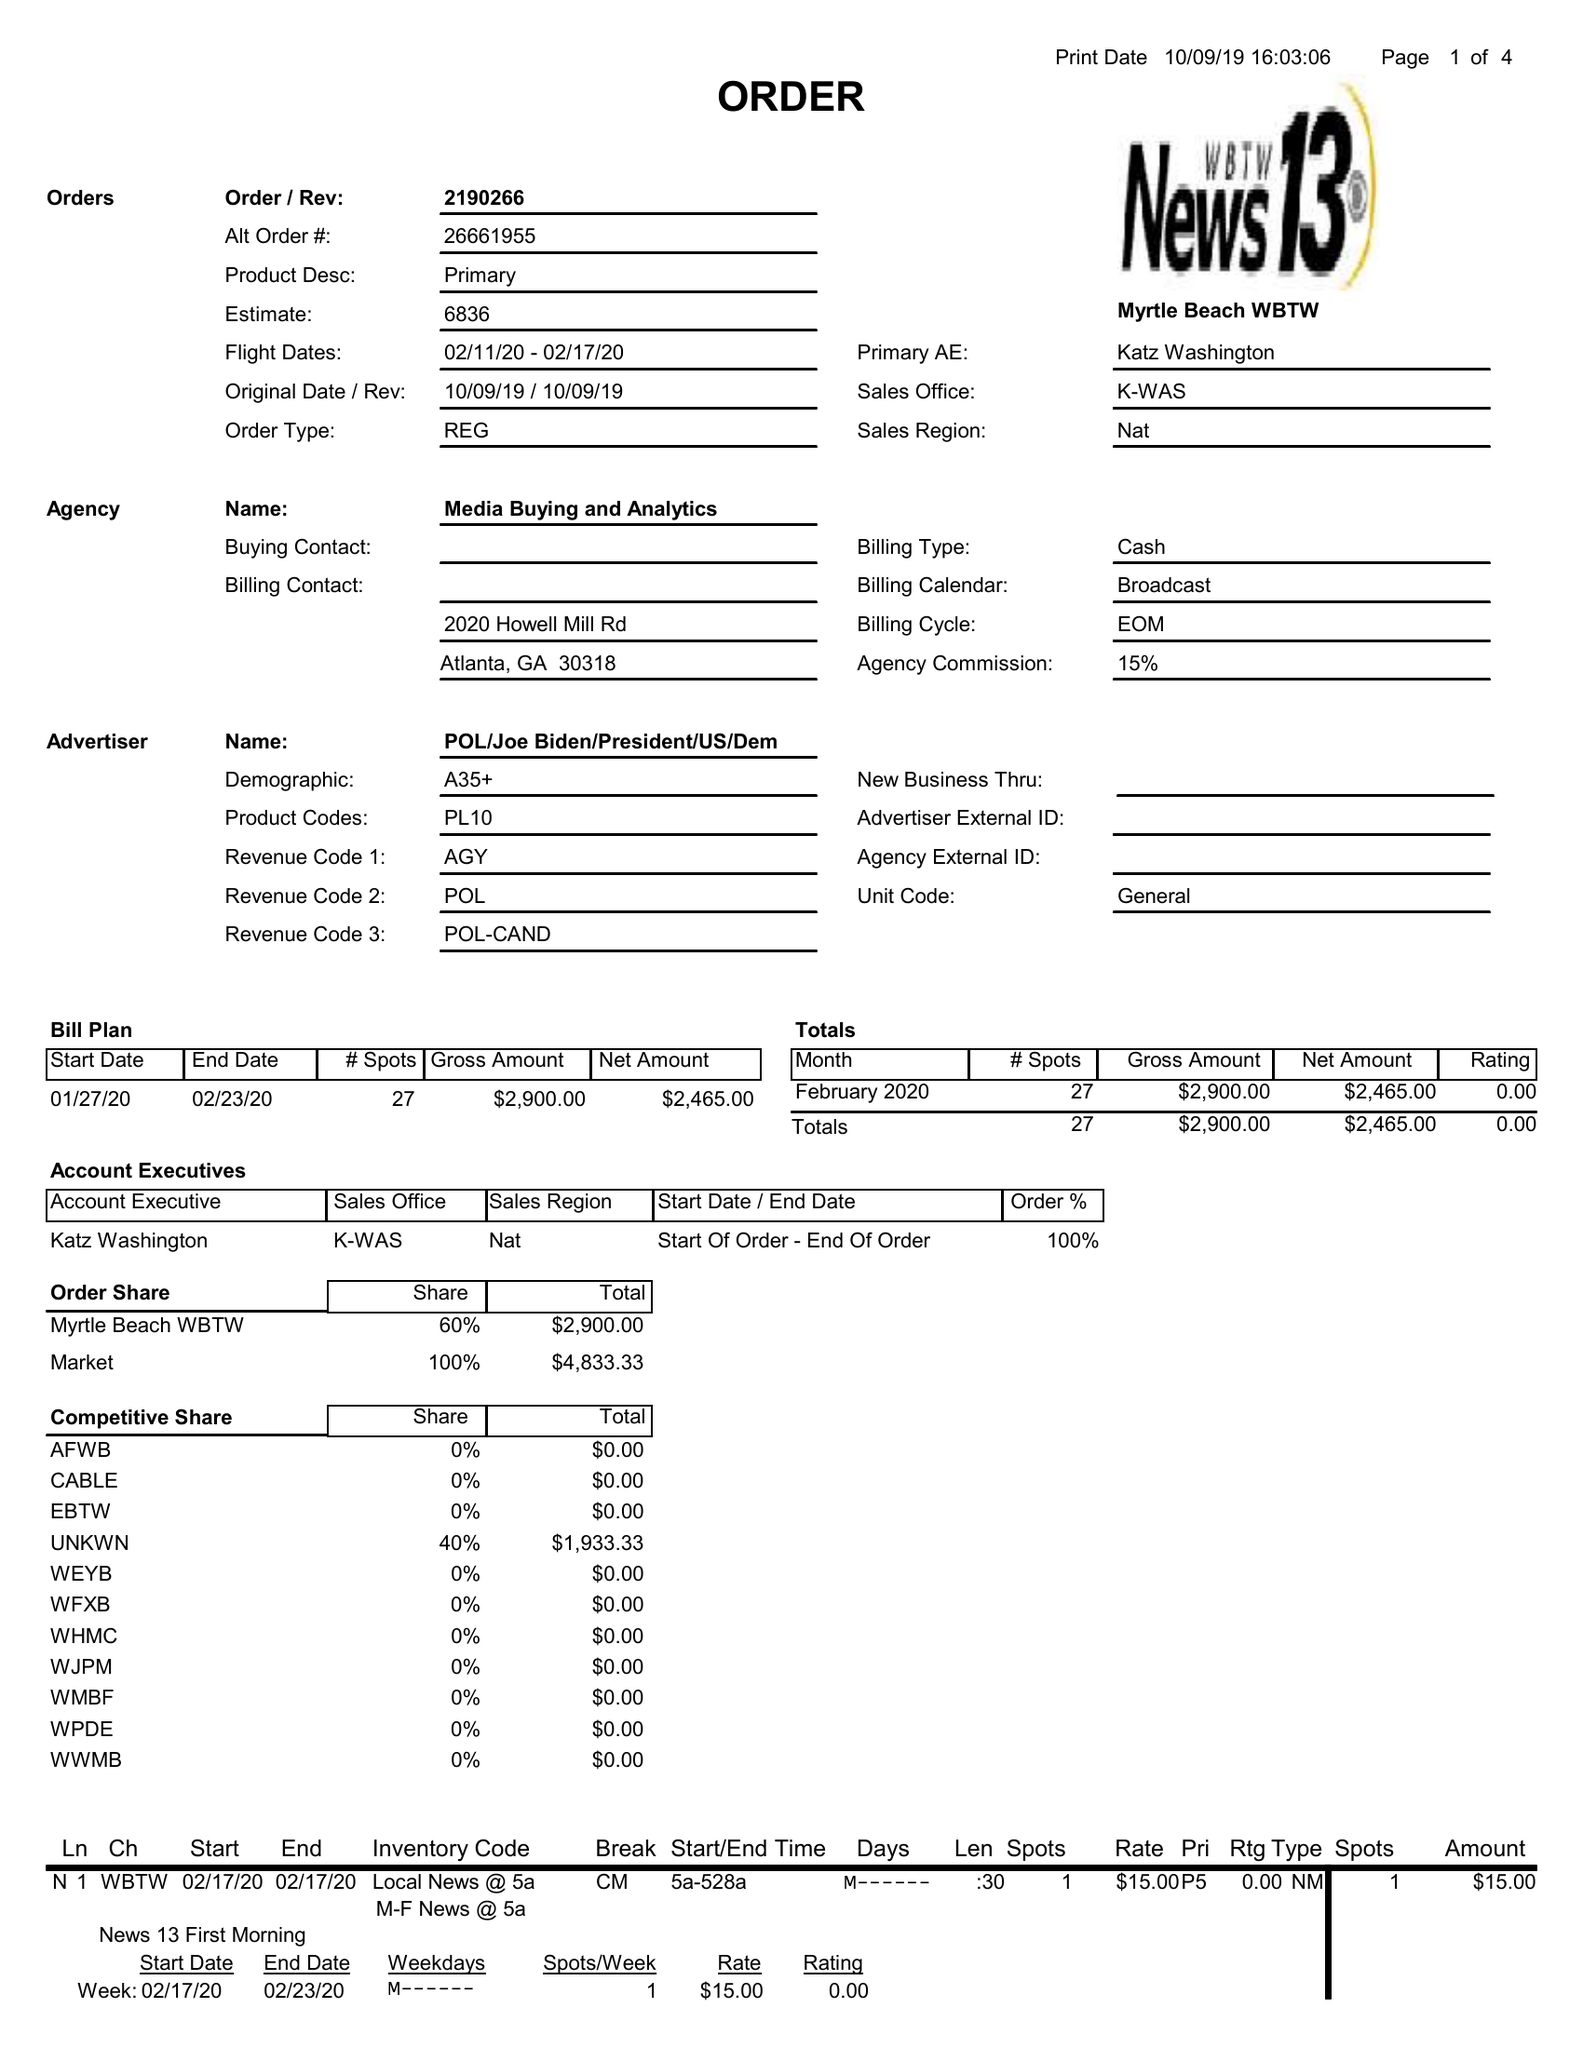What is the value for the gross_amount?
Answer the question using a single word or phrase. 2900.00 